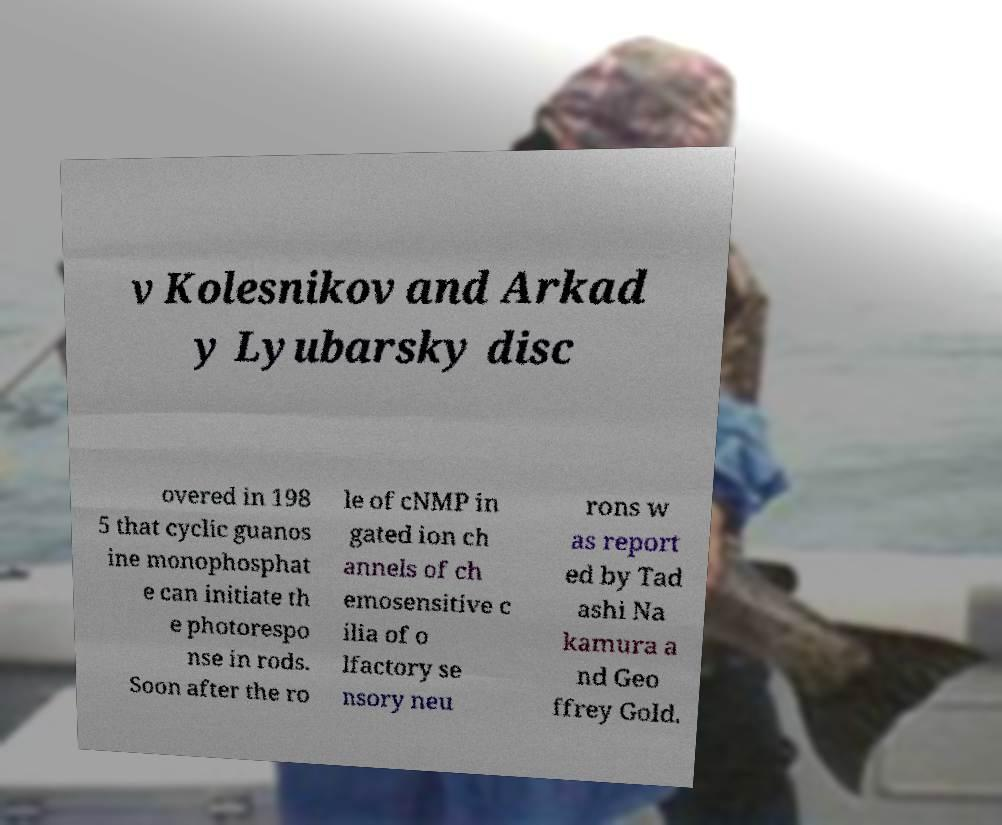There's text embedded in this image that I need extracted. Can you transcribe it verbatim? v Kolesnikov and Arkad y Lyubarsky disc overed in 198 5 that cyclic guanos ine monophosphat e can initiate th e photorespo nse in rods. Soon after the ro le of cNMP in gated ion ch annels of ch emosensitive c ilia of o lfactory se nsory neu rons w as report ed by Tad ashi Na kamura a nd Geo ffrey Gold. 